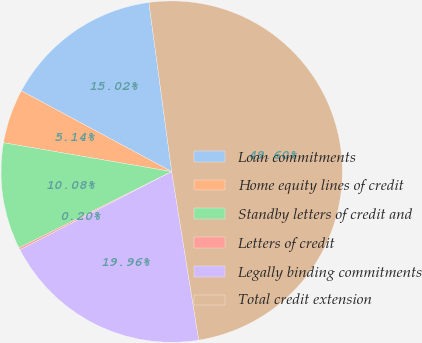Convert chart to OTSL. <chart><loc_0><loc_0><loc_500><loc_500><pie_chart><fcel>Loan commitments<fcel>Home equity lines of credit<fcel>Standby letters of credit and<fcel>Letters of credit<fcel>Legally binding commitments<fcel>Total credit extension<nl><fcel>15.02%<fcel>5.14%<fcel>10.08%<fcel>0.2%<fcel>19.96%<fcel>49.6%<nl></chart> 